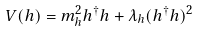Convert formula to latex. <formula><loc_0><loc_0><loc_500><loc_500>V ( h ) = m _ { h } ^ { 2 } h ^ { \dagger } h + \lambda _ { h } ( h ^ { \dagger } h ) ^ { 2 }</formula> 